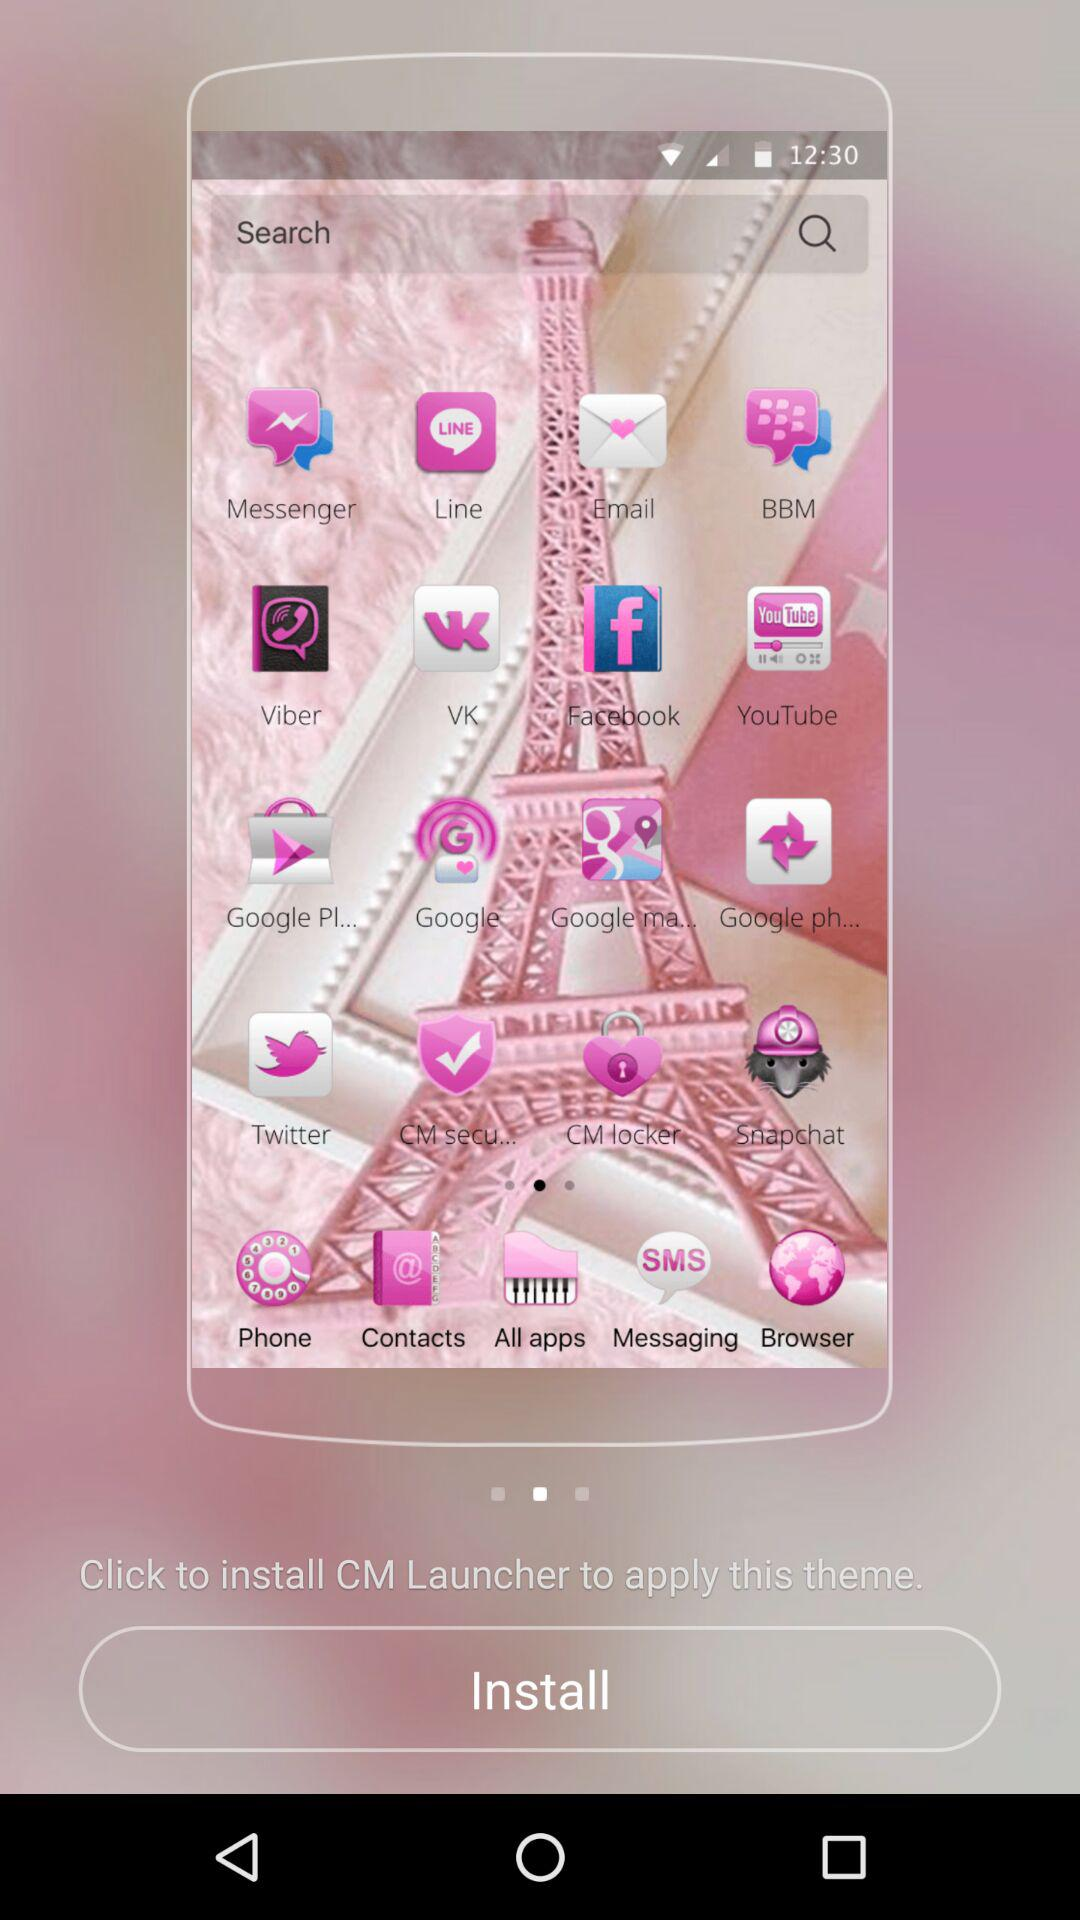What is the name of the app that needs to be installed? The name of the app that needs to be installed is "CM Launcher". 